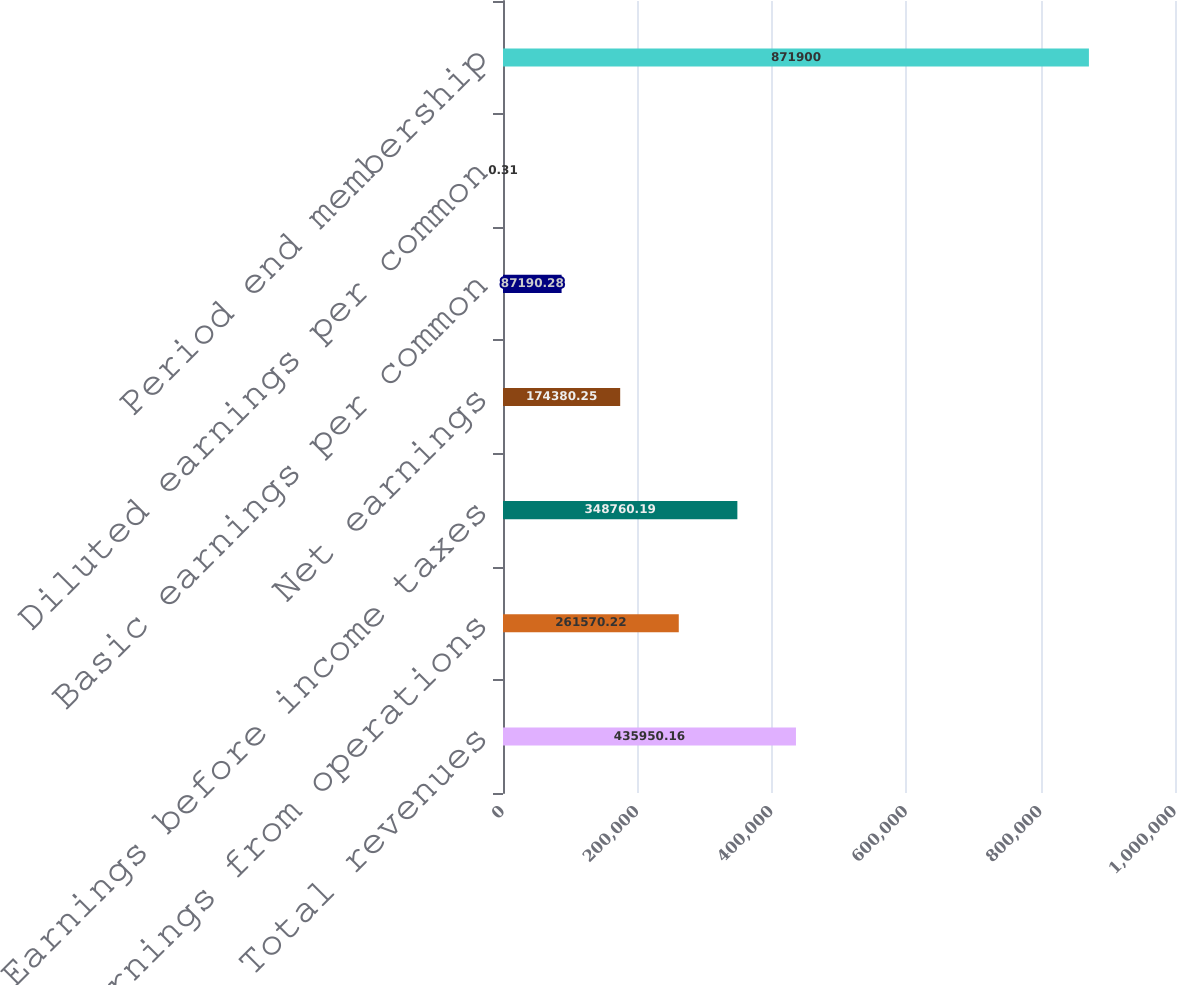<chart> <loc_0><loc_0><loc_500><loc_500><bar_chart><fcel>Total revenues<fcel>Earnings from operations<fcel>Earnings before income taxes<fcel>Net earnings<fcel>Basic earnings per common<fcel>Diluted earnings per common<fcel>Period end membership<nl><fcel>435950<fcel>261570<fcel>348760<fcel>174380<fcel>87190.3<fcel>0.31<fcel>871900<nl></chart> 